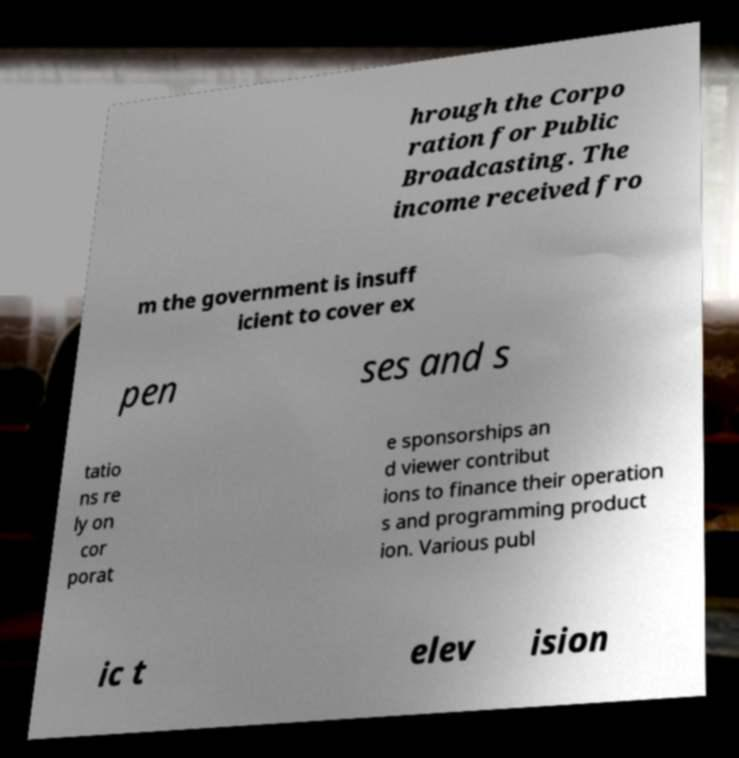Please read and relay the text visible in this image. What does it say? hrough the Corpo ration for Public Broadcasting. The income received fro m the government is insuff icient to cover ex pen ses and s tatio ns re ly on cor porat e sponsorships an d viewer contribut ions to finance their operation s and programming product ion. Various publ ic t elev ision 